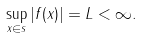Convert formula to latex. <formula><loc_0><loc_0><loc_500><loc_500>\sup _ { x \in \real s } | f ( x ) | = L < \infty .</formula> 